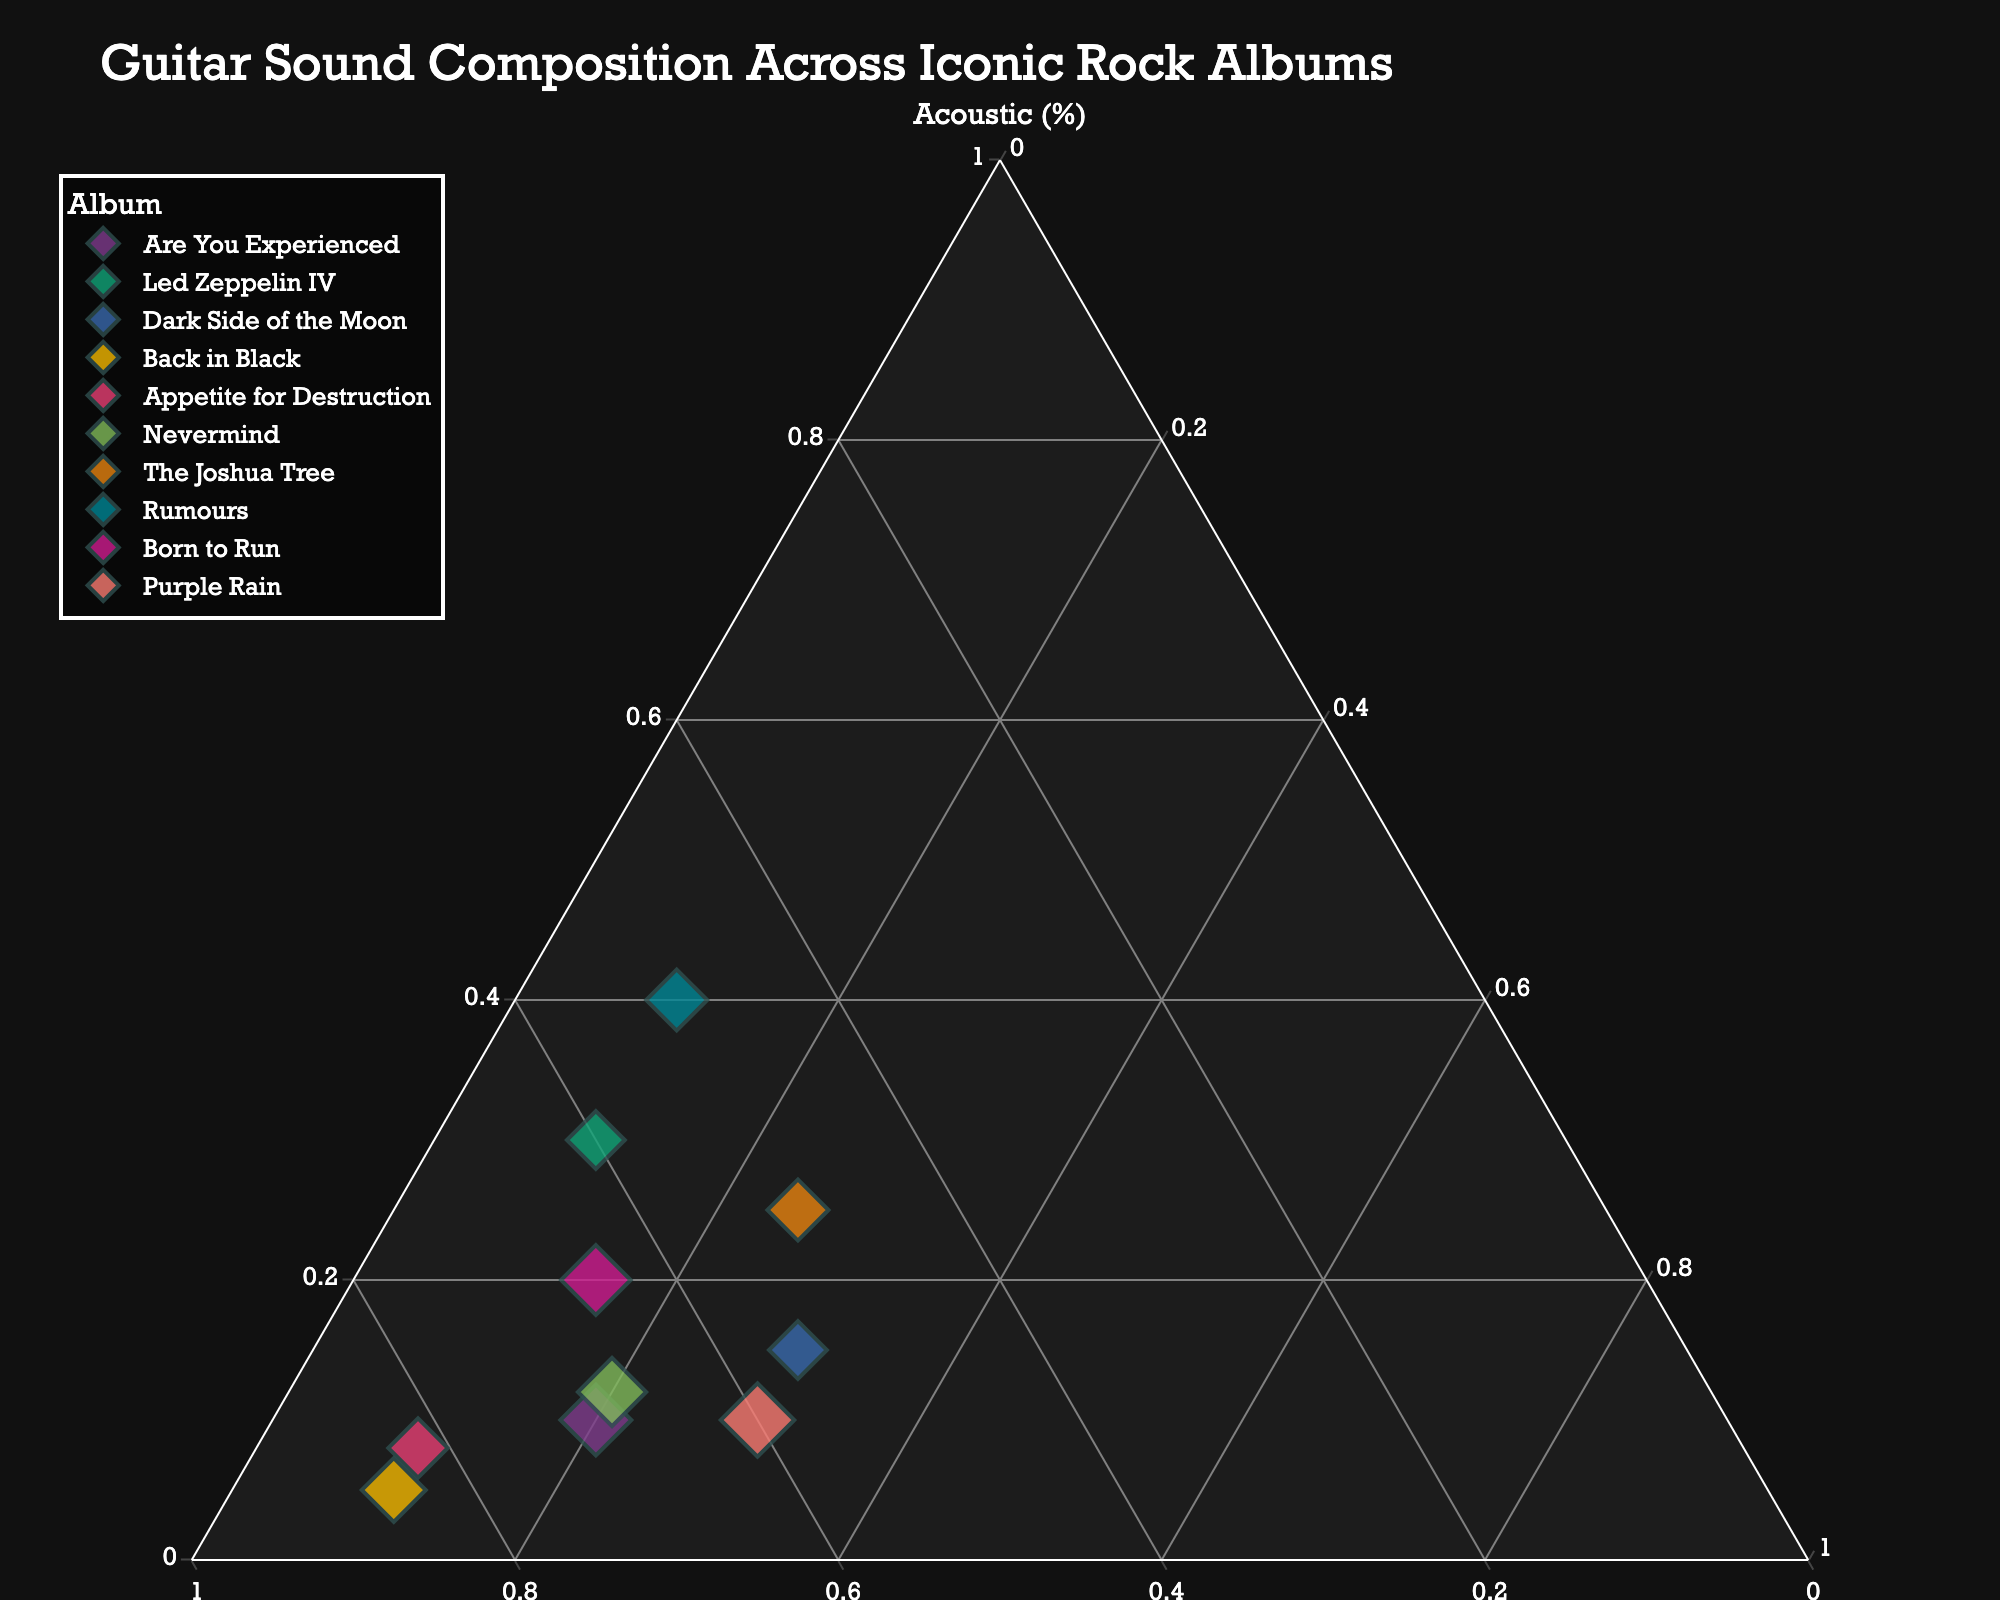What is the title of the ternary plot? The title of a chart is usually displayed at the top and is often the largest text on the plot, making it easy to spot.
Answer: Guitar Sound Composition Across Iconic Rock Albums Which album has the highest proportion of electric guitar sounds? Look for the album's data point closest to the electric axis, which indicates a higher proportion of electric guitar sounds.
Answer: Back in Black What is the album with an equal balance of acoustic and effects-driven sounds? Find the data point where the acoustic and effects-driven values are equal, and the remaining portion is of electric sound. From the figure, find the album label closest to such a point.
Answer: Dark Side of the Moon Which album shows the highest proportion of acoustic sounds? Identify the data point closest to the acoustic axis, representing the highest proportion of acoustic sounds.
Answer: Rumours Compare "The Joshua Tree" and "Purple Rain" in terms of effects-driven guitar sounds. Which album uses more effects? Check the percent values of the effects-driven axis for both albums and see which one has a higher value.
Answer: Both use 30% effects How do "Are You Experienced" and "Nevermind" compare in their acoustic guitar proportions? Compare the data points of both albums near the acoustic axis and note which one is closer to it.
Answer: Nevermind has more acoustic sounds Which three albums have a mix where electric guitar sounds dominate? Look for albums where the data points are closest to the electric axis, indicating that electric sounds make up the largest portion.
Answer: Are You Experienced, Back in Black, Appetite for Destruction What's the average proportion of acoustic sounds across all albums? Sum the acoustic proportions of all albums and then divide by the number of albums: (0.10+0.30+0.15+0.05+0.08+0.12+0.25+0.40+0.20+0.10)/10 = 1.75/10
Answer: 0.175 Which album in the plot exhibits the highest diversity in sound (i.e., has the most balanced mix of all three types)? Look for the album whose data point is most equidistant from all the three axes, indicating a balanced mix of acoustic, electric, and effects-driven sounds.
Answer: Dark Side of the Moon Which album has a greater proportion of effects-driven sounds, "Led Zeppelin IV" or "The Joshua Tree"? Refer to the percent values on the effects axis for both albums and see which one is higher.
Answer: The Joshua Tree 